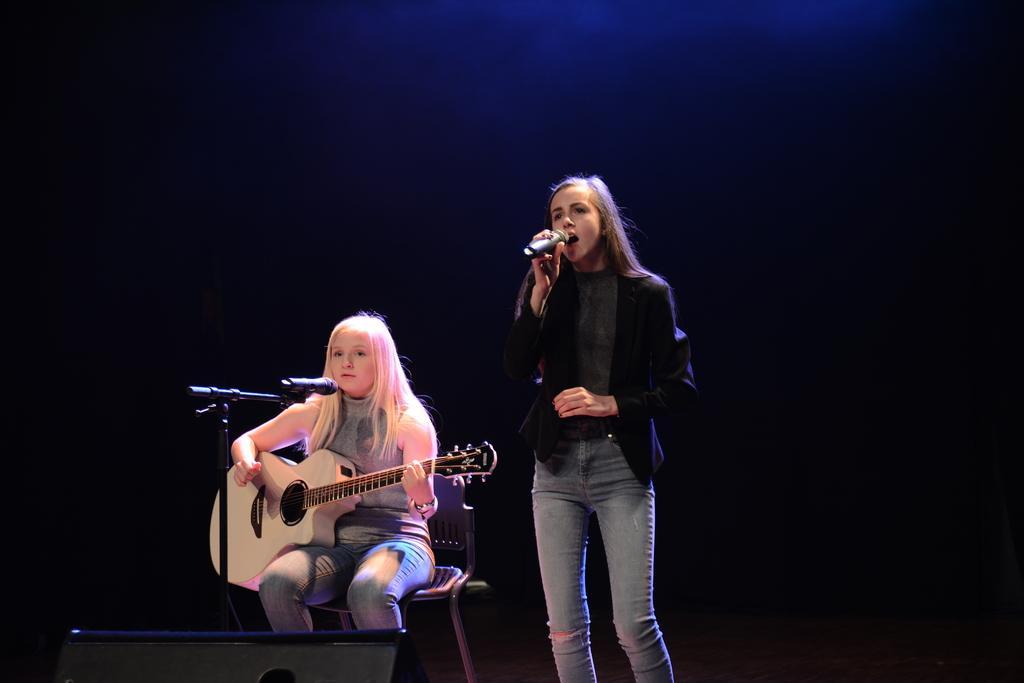Describe this image in one or two sentences. Background is dark. We can see a girl sitting on a chair in front of a mike and playing guitar. Aside to this girl we can see other girl standing, holding a mike in her hand and singing. 